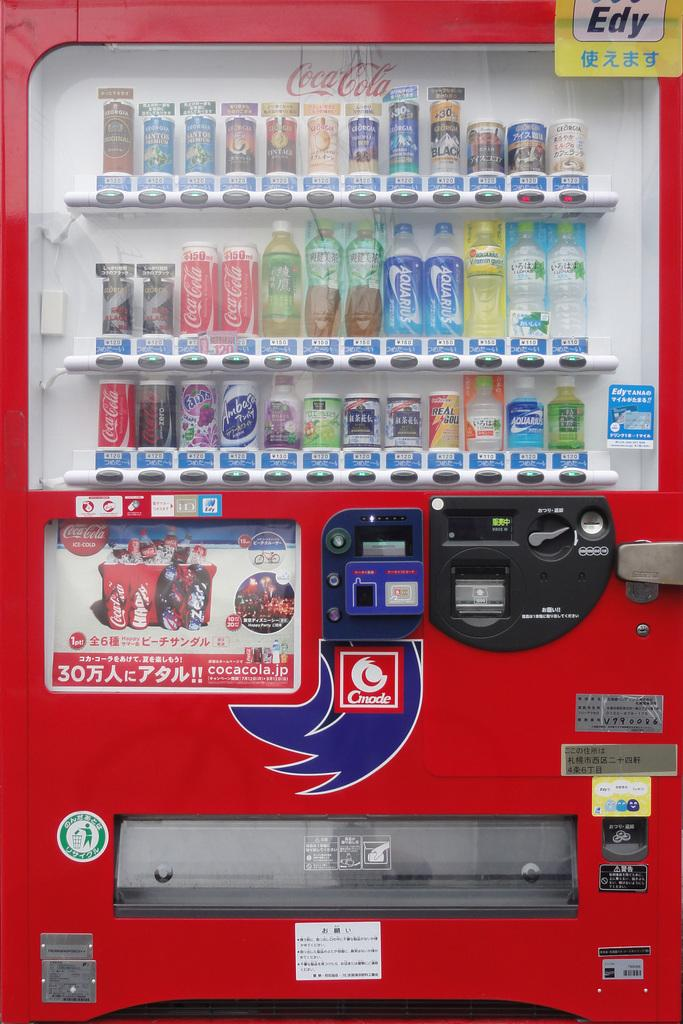What type of machine is present in the image? There is a vending machine in the image. What items can be found inside the vending machine? The vending machine contains bottles and tins. How can customers identify the products in the vending machine? There are labels on the vending machine. What book is the actor reading in the image? There is no book or actor present in the image; it features a vending machine with bottles and tins. What song is playing in the background of the image? There is no music or sound present in the image; it only shows a vending machine with labels and products. 